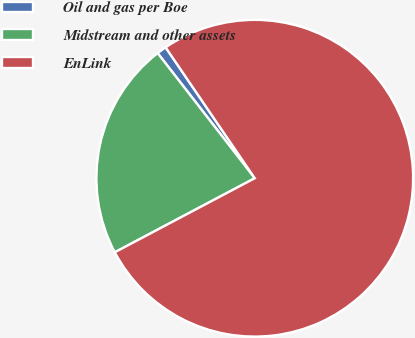<chart> <loc_0><loc_0><loc_500><loc_500><pie_chart><fcel>Oil and gas per Boe<fcel>Midstream and other assets<fcel>EnLink<nl><fcel>0.99%<fcel>22.24%<fcel>76.77%<nl></chart> 